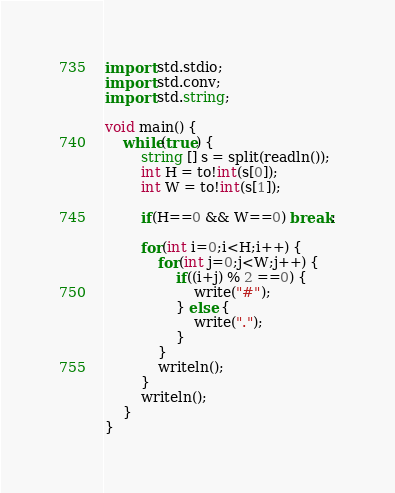Convert code to text. <code><loc_0><loc_0><loc_500><loc_500><_D_>import std.stdio;
import std.conv;
import std.string;

void main() {
    while(true) {
        string [] s = split(readln());
        int H = to!int(s[0]);
        int W = to!int(s[1]);
        
        if(H==0 && W==0) break;
        
        for(int i=0;i<H;i++) {
        	for(int j=0;j<W;j++) {
        		if((i+j) % 2 ==0) {
        			write("#");
        		} else {
        			write(".");
        		}
        	}
        	writeln();
        }
        writeln();
    }
}</code> 